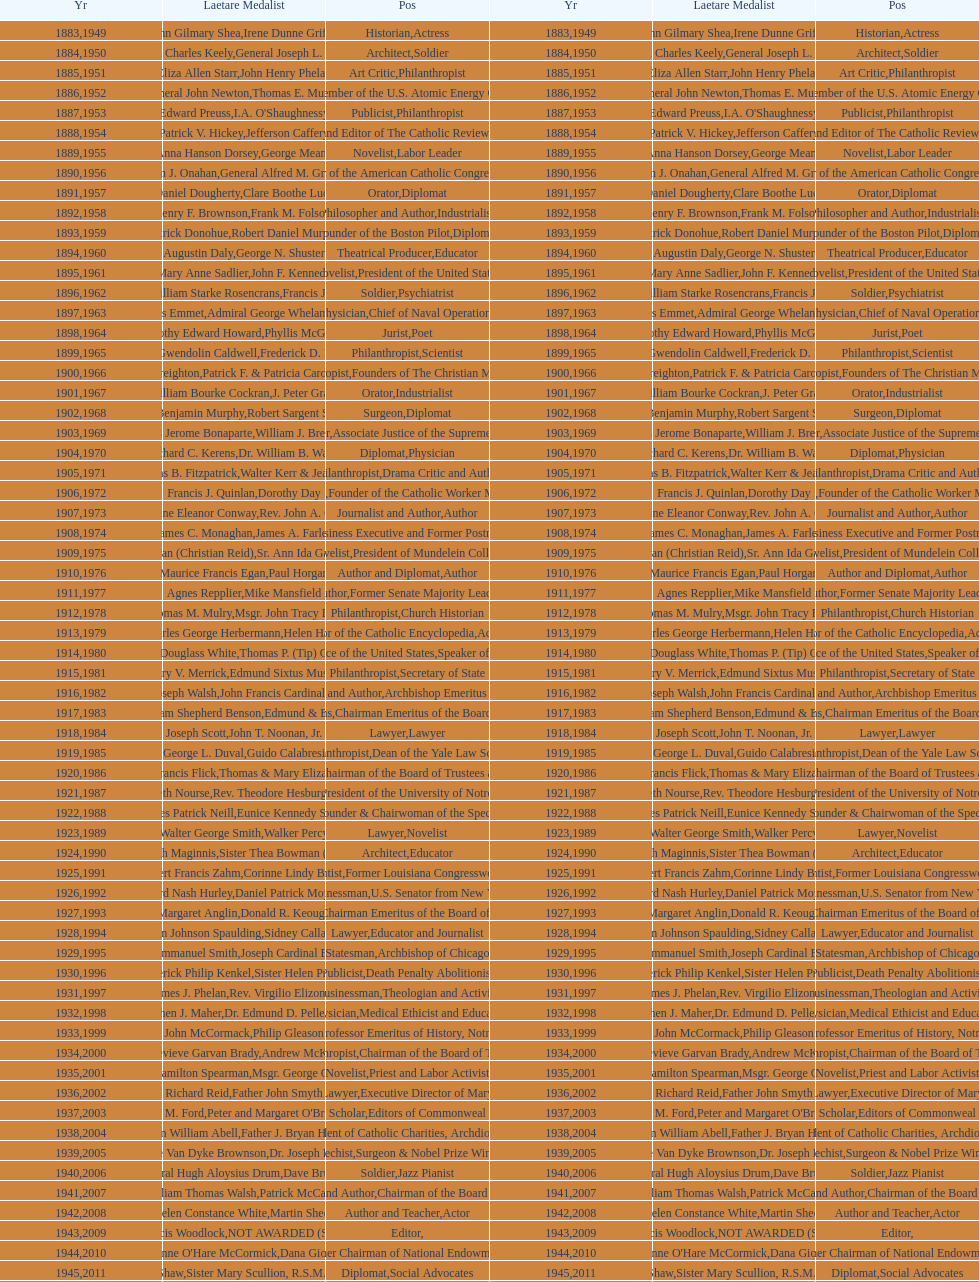What is the name of the laetare medalist listed before edward preuss? General John Newton. 